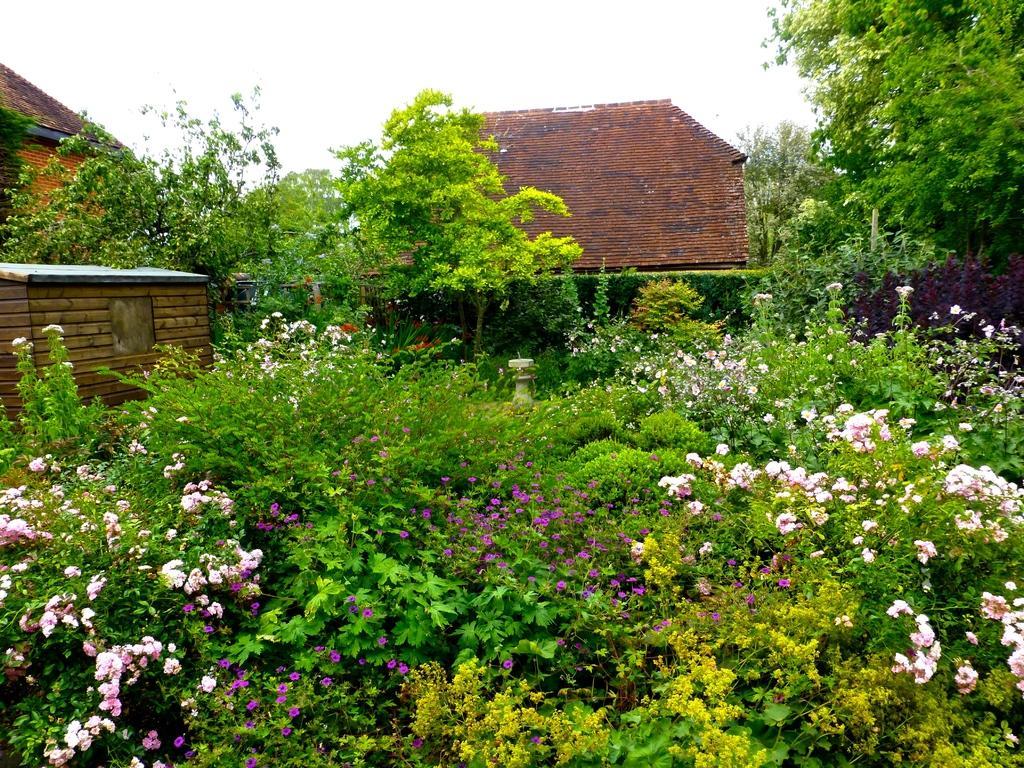How would you summarize this image in a sentence or two? In this picture we can see some plants and these are the flowers. There are some trees. This is the house, and there is a sky. 